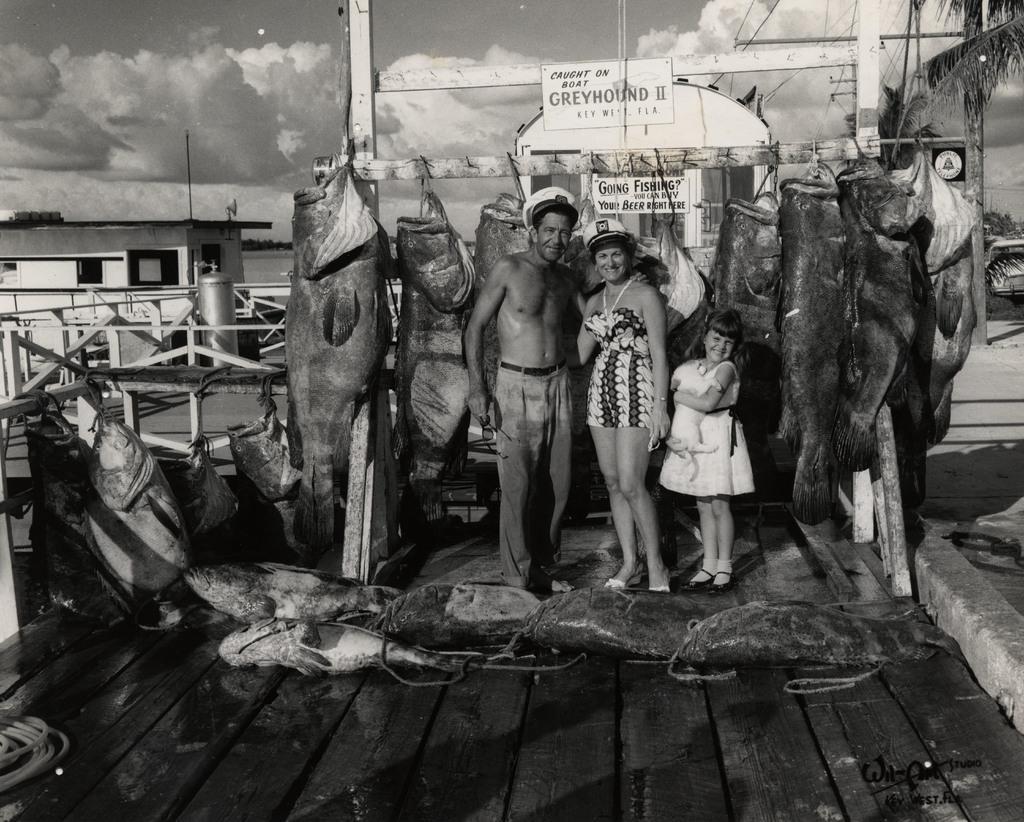How would you summarize this image in a sentence or two? This is a black and white image. In this image I can see a man, a woman and a girl are standing, smiling and giving pose for the picture. Here I can see some fishes on the floor and few are hanging to a stick at the back of these people. On the right side I can see some trees and on the left side there is a shed and also there is a railing. On the top of the image I can see the sky and clouds. 